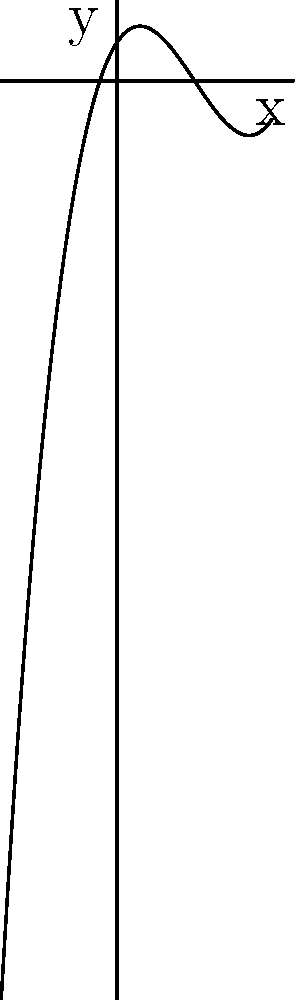Look at the graph. What is the degree of this polynomial? To determine the degree of a polynomial from its graph, we need to consider these steps:

1. Count the number of turning points (peaks and troughs):
   This graph has 2 turning points.

2. Remember the rule: The maximum number of turning points is (degree - 1).
   So, (degree - 1) = 2
   
3. Solve for the degree:
   degree = 2 + 1 = 3

4. Check the end behavior:
   As x goes to positive infinity, y goes to positive infinity.
   As x goes to negative infinity, y goes to negative infinity.
   This confirms an odd-degree polynomial (consistent with degree 3).

Therefore, the polynomial has a degree of 3.
Answer: 3 